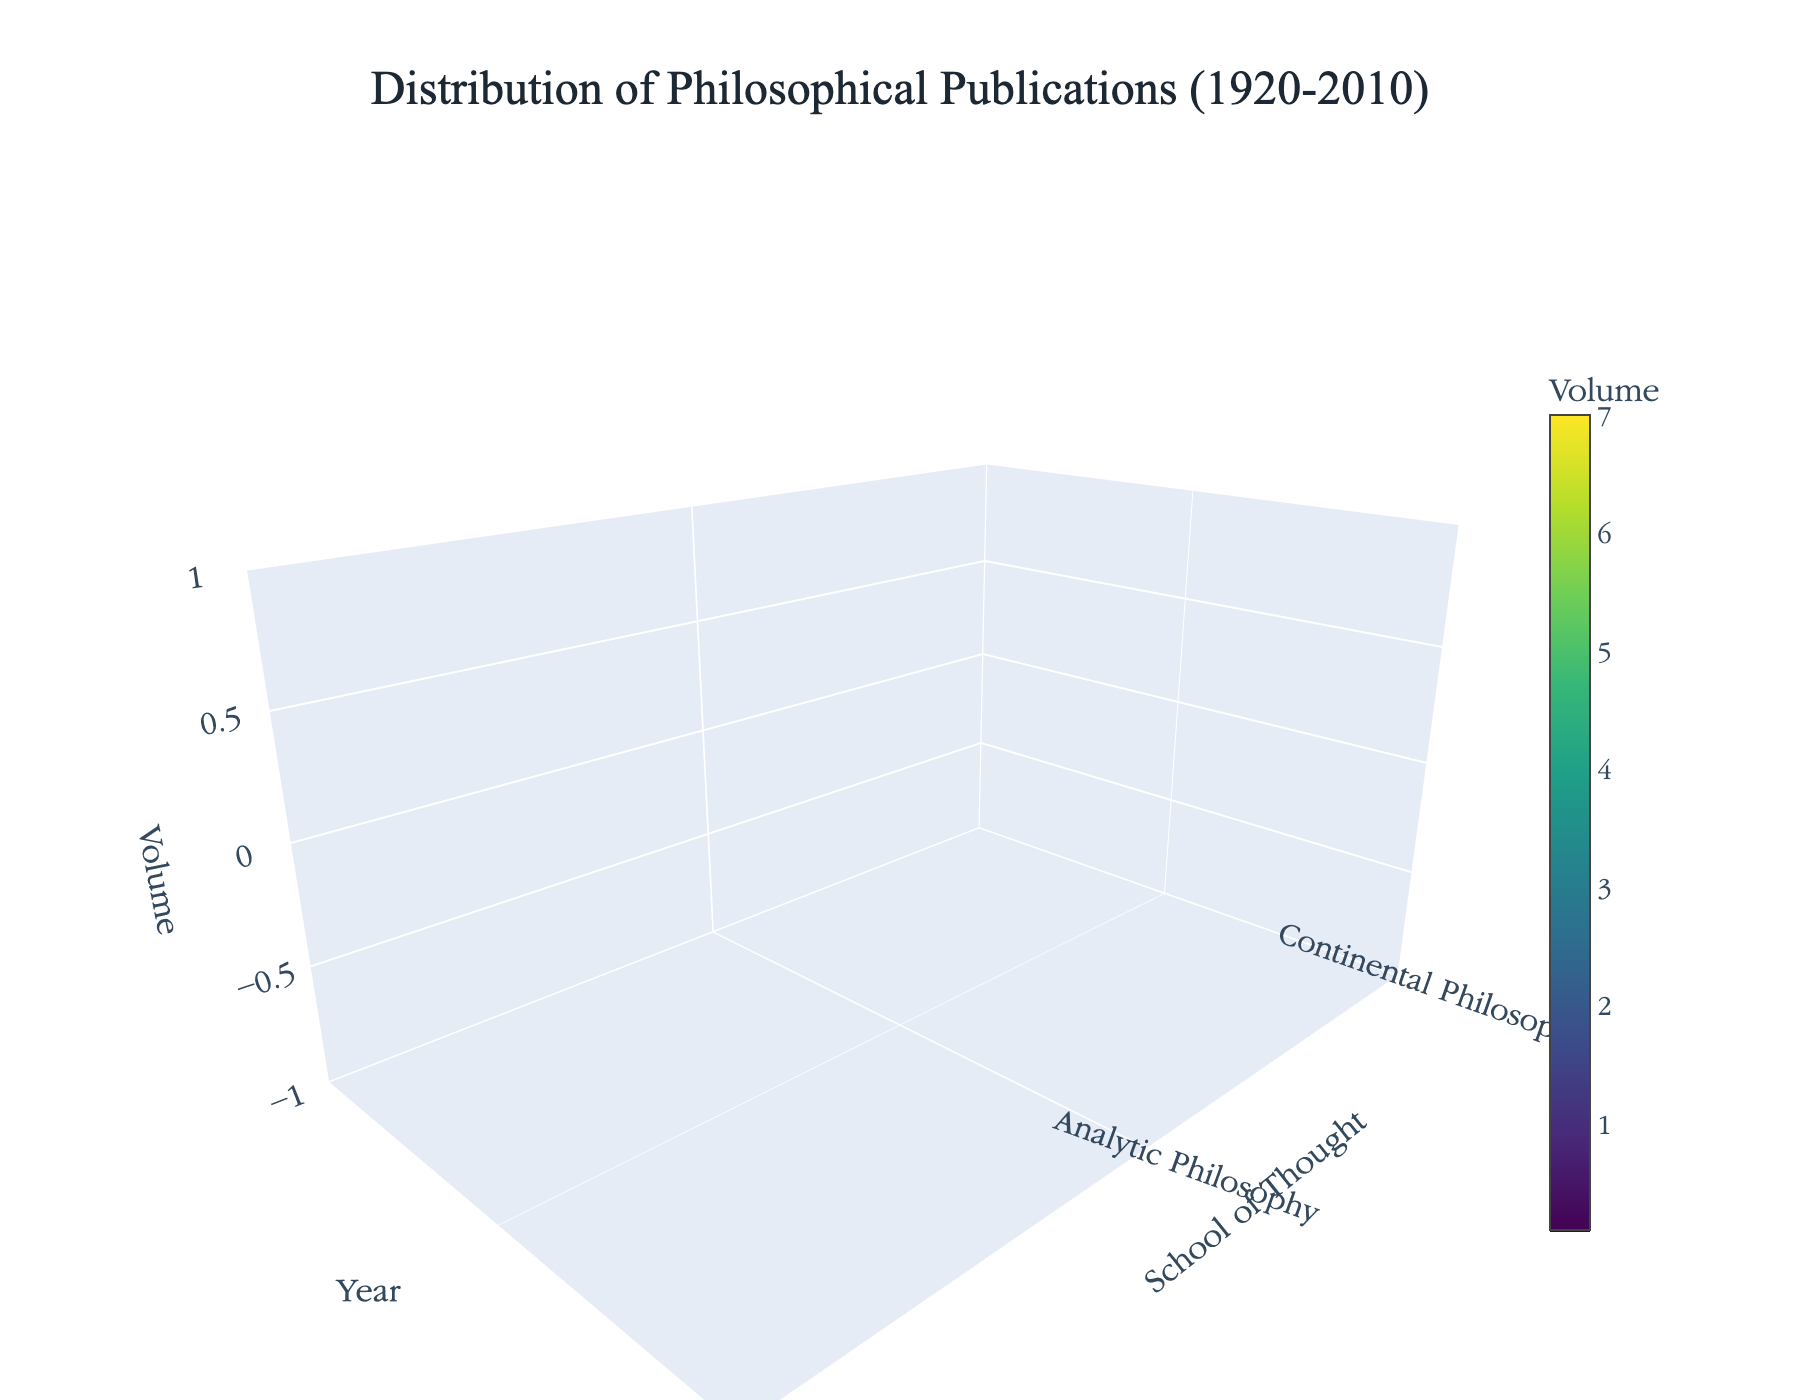what is the title of the figure? The title is typically at the top of the figure. In this case, it reads "Distribution of Philosophical Publications (1920-2010)"
Answer: Distribution of Philosophical Publications (1920-2010) Which year shows the highest volume of publications for Analytic Philosophy? Examine the 'Volume' axis (z-axis) for the highest value along the 'Year' axis (x-axis) and 'School of Thought' axis (y-axis). The highest volume for Analytic Philosophy is in 2010.
Answer: 2010 How does the volume of Continental Philosophy publications in 1980 compare to those in 1950? Compare the values on the y-axis for Continental Philosophy at two points on the x-axis (1980 and 1950). The volume is higher in 1980 than in 1950.
Answer: Higher What is the average volume for Pragmatism publications across all years? Identify the volumes of Pragmatism for all years, sum them, and then divide by the number of years. The volumes are: 1.1, 1.8, 2.4, and 3.1. The average is (1.1 + 1.8 + 2.4 + 3.1) / 4 = 2.1.
Answer: 2.1 Which school of thought has the least variation in publication volume over time? Assess the variation in volumes for each school by observing the z-values. Existentialism shows the least variation with volumes changing minorly over the years.
Answer: Existentialism 